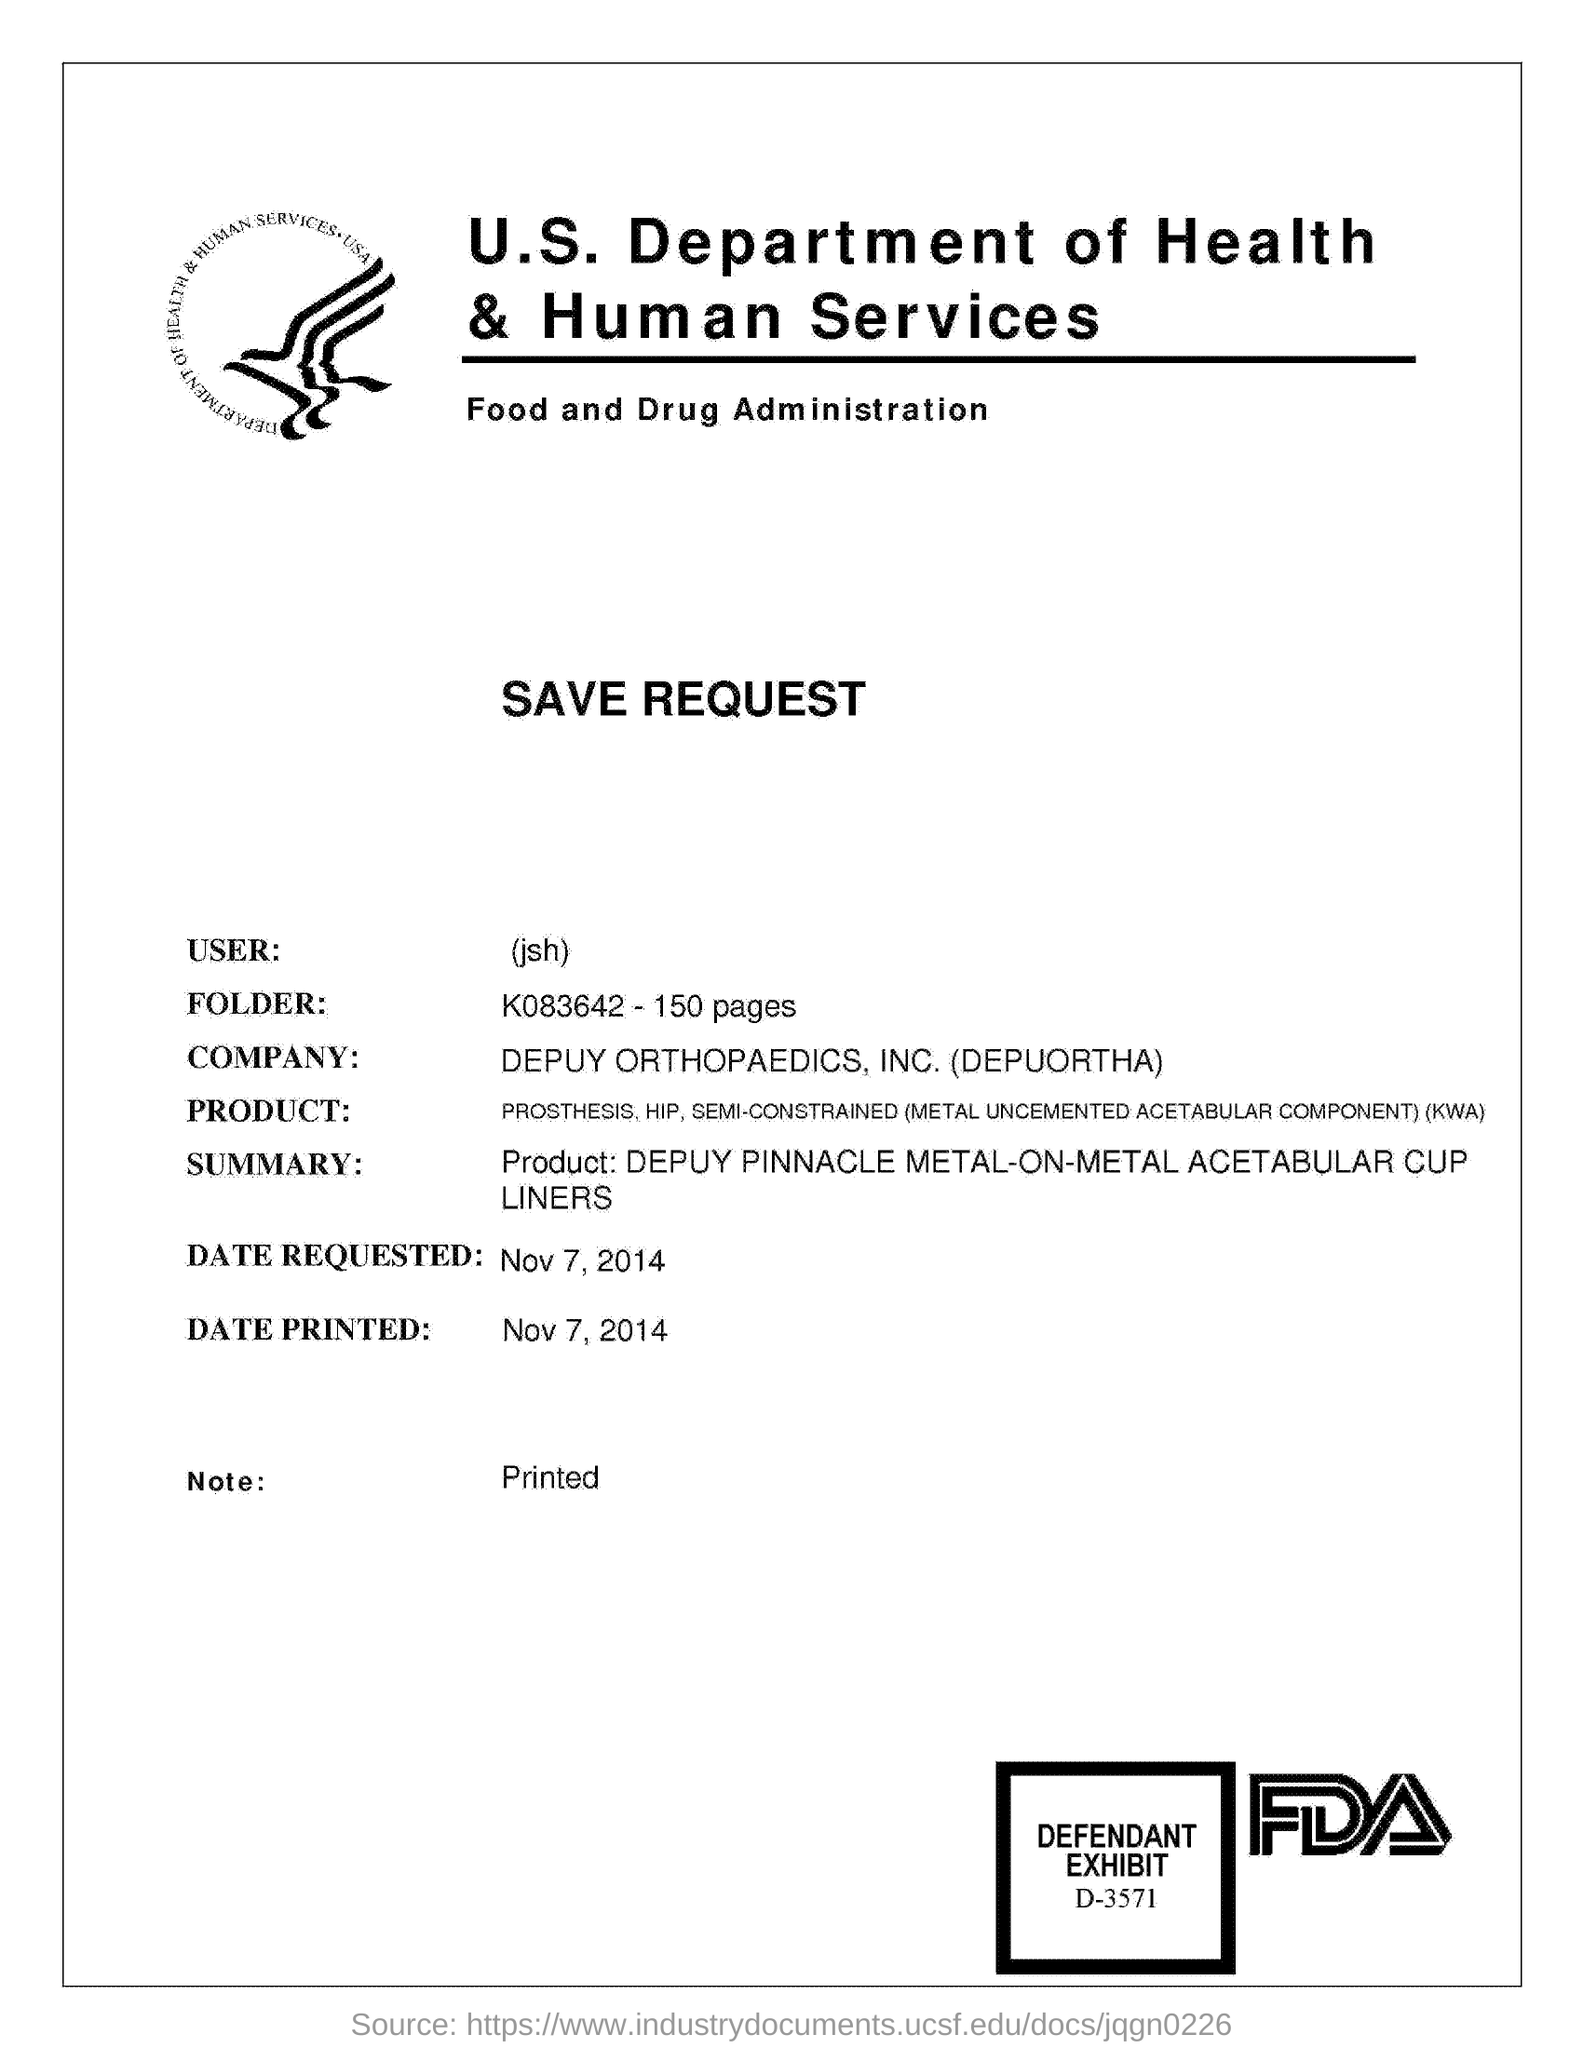Mention a couple of crucial points in this snapshot. The U.S. Department of Health & Human Services is mentioned. Depuy Orthopaedics, Inc. (also known as Depuortha) is mentioned in the document. The date requested is on November 7, 2014. The folder that is being referred to is K083642... The date "November 7, 2014" will be printed. 